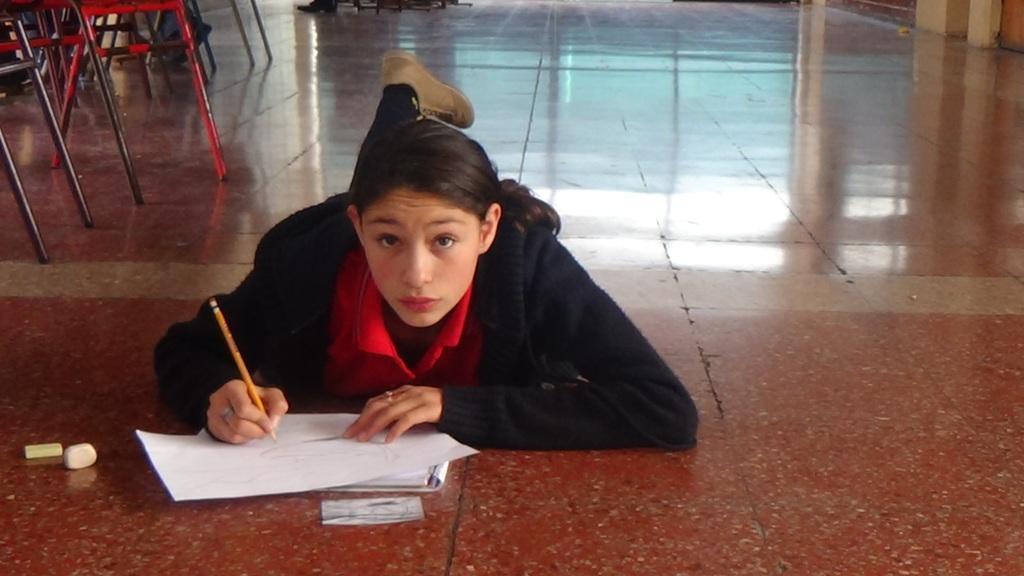Describe this image in one or two sentences. In the image a woman is lying on the floor and holding a pen and writing and there are some erasers. At the top of the image there are some chairs. 